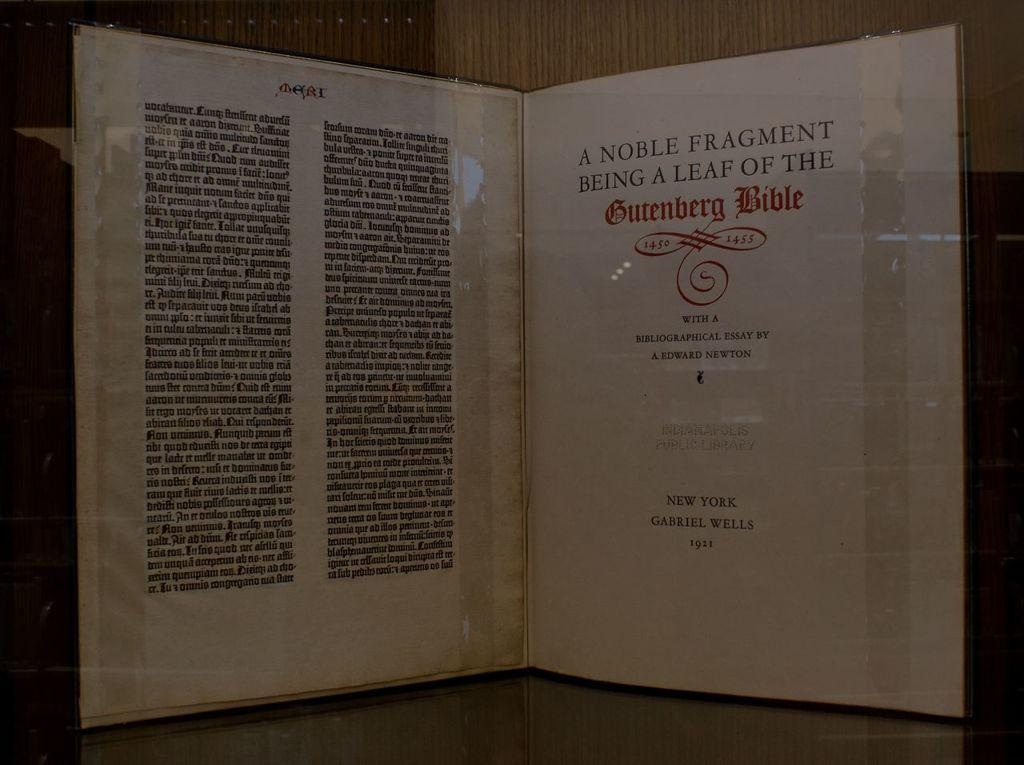<image>
Describe the image concisely. An old preserved page of the Gutenberg Bible. 